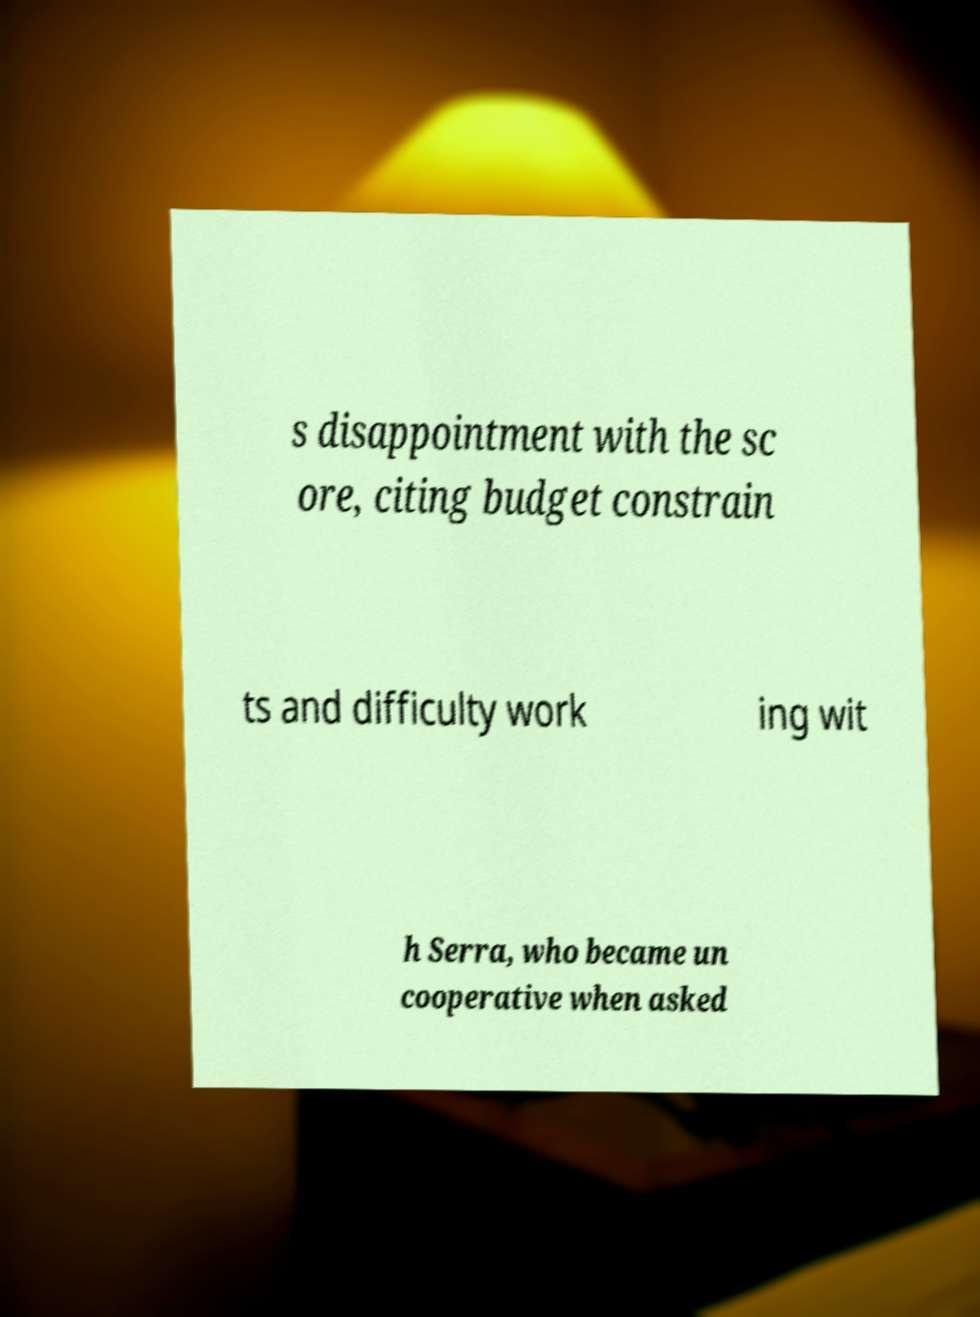Can you read and provide the text displayed in the image?This photo seems to have some interesting text. Can you extract and type it out for me? s disappointment with the sc ore, citing budget constrain ts and difficulty work ing wit h Serra, who became un cooperative when asked 